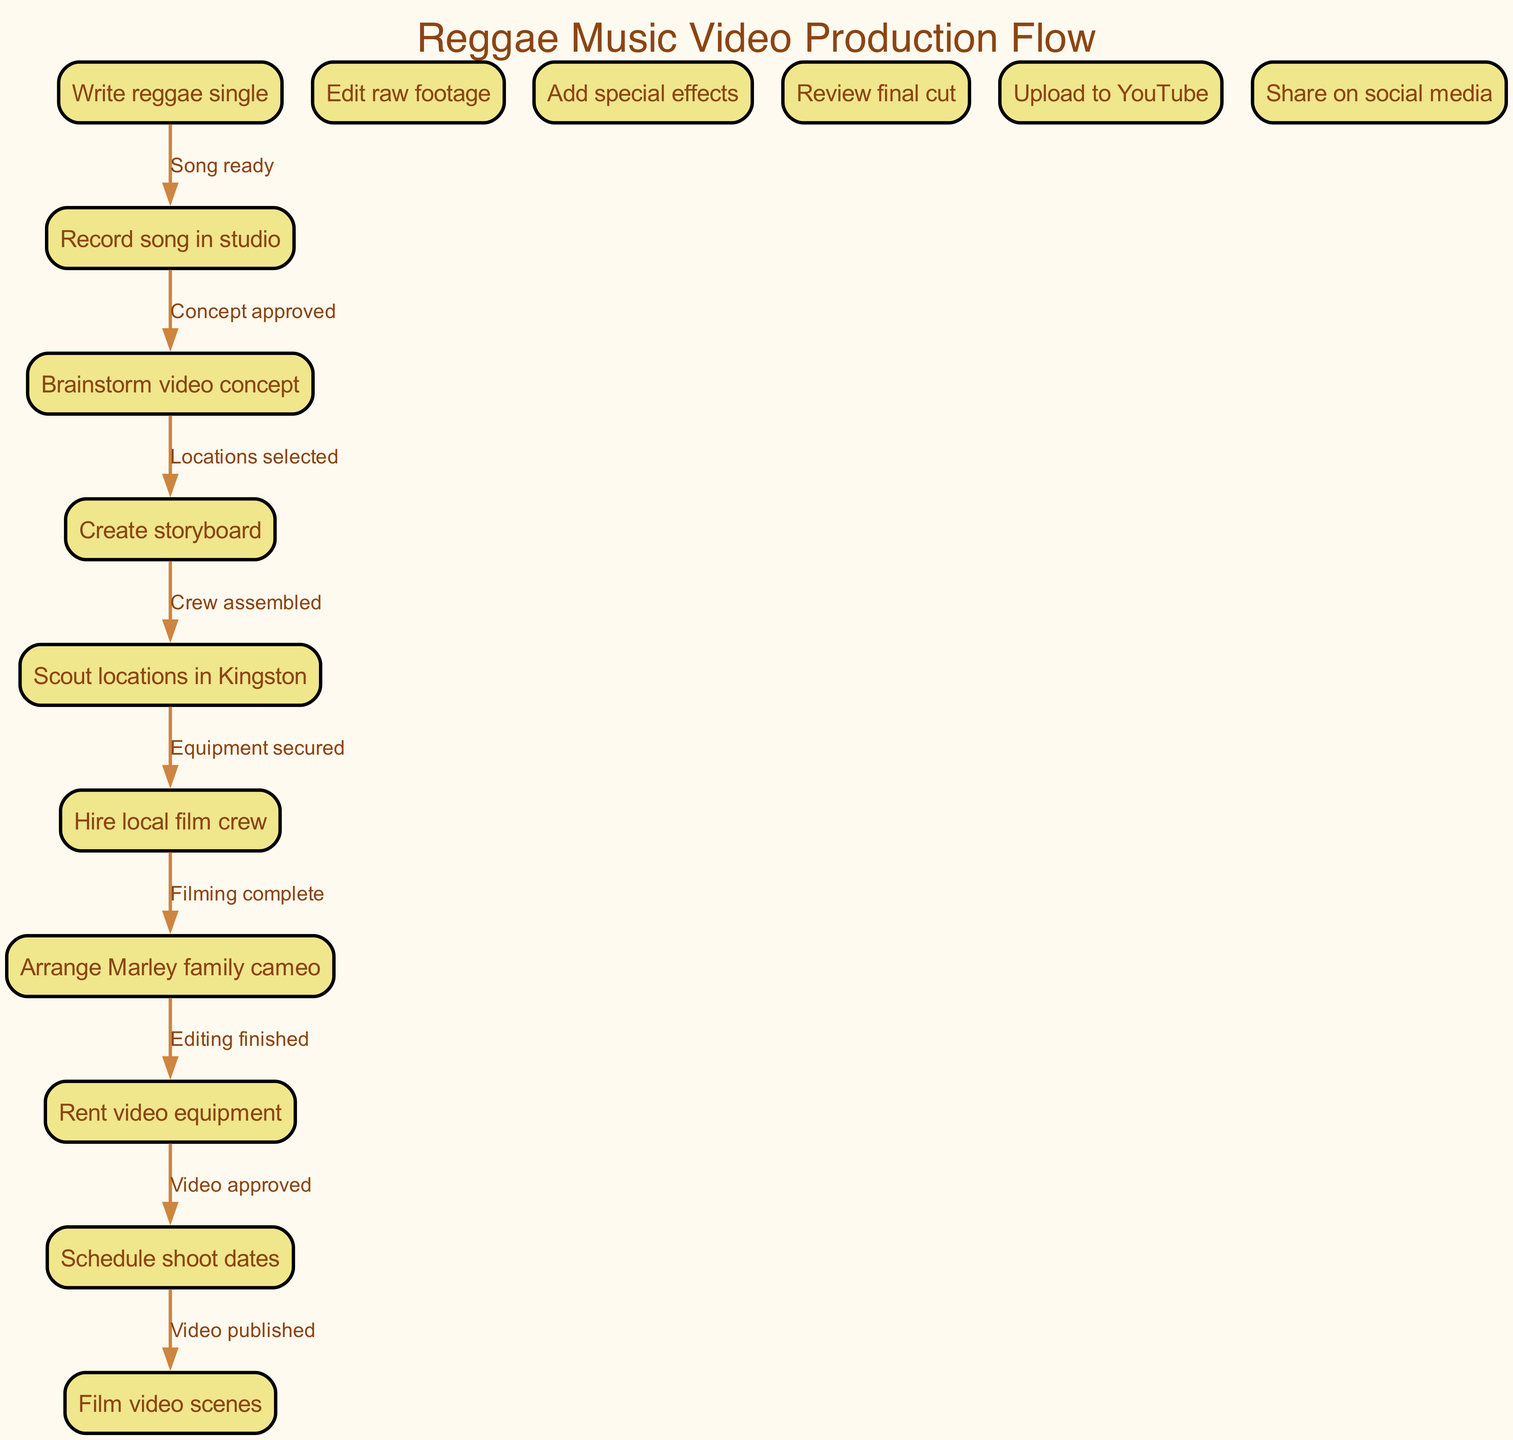What is the first node in the diagram? The first node listed in the diagram is "Write reggae single." It is the starting point of the process as indicated by its position and the flow of edges that lead away from it.
Answer: Write reggae single How many nodes are in the diagram? By counting the nodes directly mentioned in the provided data, there are a total of 15 nodes specified in the diagram, representing distinct steps in the music video production process.
Answer: 15 What is the last node in the diagram? The last node in the diagram is "Share on social media," marking the completion of the entire process after the video is published.
Answer: Share on social media Which nodes are connected by the edge labeled "Filming complete"? The edge labeled "Filming complete" connects the nodes "Film video scenes" and "Edit raw footage." This relationship indicates the transition from filming to editing the footage.
Answer: Film video scenes, Edit raw footage What is the relationship between "Schedule shoot dates" and "Hire local film crew"? "Schedule shoot dates" must occur after "Hire local film crew." This indicates that hiring the crew is a prerequisite for scheduling the shoot dates, as the crew needs to be in place before the production can proceed.
Answer: Hire local film crew, Schedule shoot dates What step comes after "Editing finished"? The step that comes after "Editing finished" is "Video approved." This signifies the completion of the editing phase, followed by a review to approve the final product before publication.
Answer: Video approved How many edges connect the nodes in this diagram? There are 14 edges connecting the nodes in this diagram, which represent the various transitions and relationships between the different steps in the process of planning and executing a music video shoot.
Answer: 14 Which node involves arranging for a cameo appearance? The node "Arrange Marley family cameo" explicitly involves the task of coordinating the participation of the Marley family in the music video, highlighting the connection to reggae music heritage.
Answer: Arrange Marley family cameo What is the final action taken in the diagram? The final action taken in the diagram is "Upload to YouTube," which indicates the last step in the process where the finished video is shared on the platform.
Answer: Upload to YouTube 